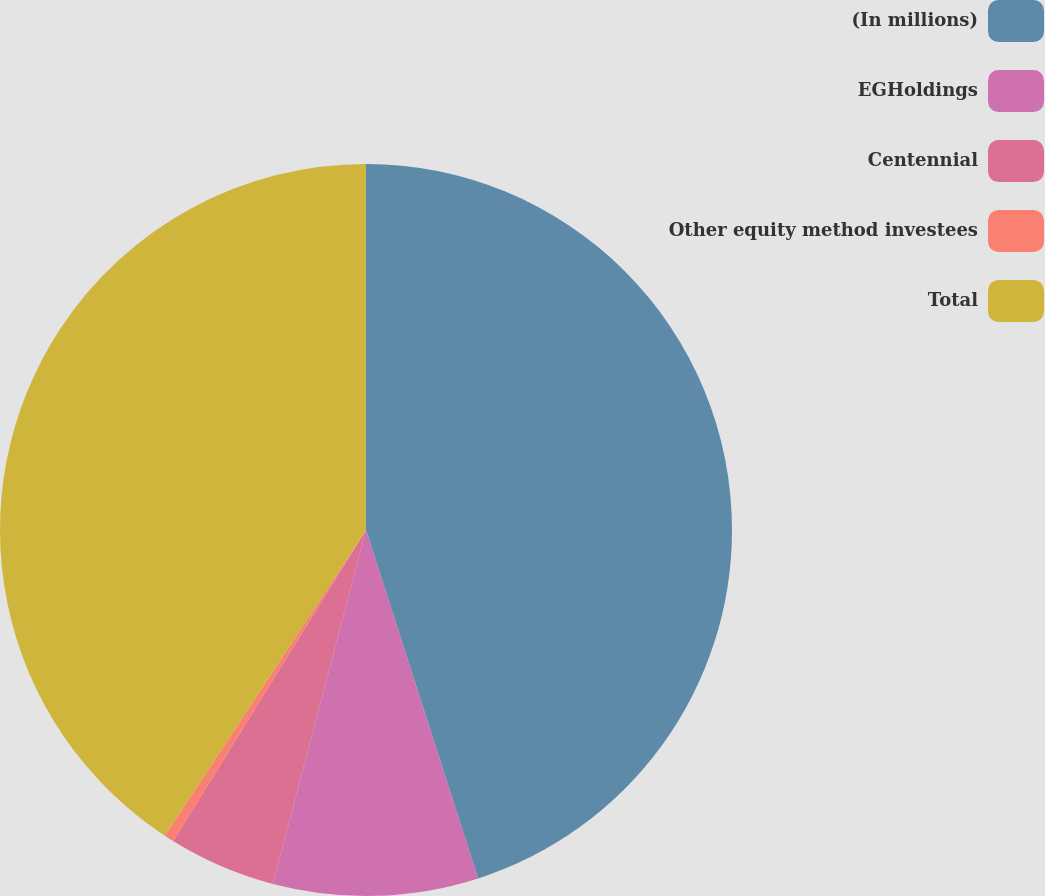<chart> <loc_0><loc_0><loc_500><loc_500><pie_chart><fcel>(In millions)<fcel>EGHoldings<fcel>Centennial<fcel>Other equity method investees<fcel>Total<nl><fcel>45.04%<fcel>9.05%<fcel>4.74%<fcel>0.43%<fcel>40.73%<nl></chart> 